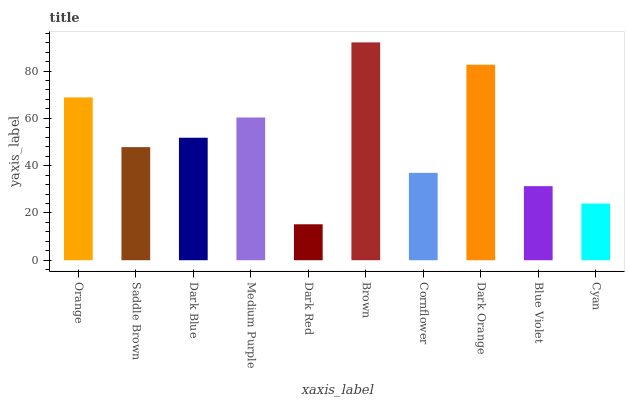Is Saddle Brown the minimum?
Answer yes or no. No. Is Saddle Brown the maximum?
Answer yes or no. No. Is Orange greater than Saddle Brown?
Answer yes or no. Yes. Is Saddle Brown less than Orange?
Answer yes or no. Yes. Is Saddle Brown greater than Orange?
Answer yes or no. No. Is Orange less than Saddle Brown?
Answer yes or no. No. Is Dark Blue the high median?
Answer yes or no. Yes. Is Saddle Brown the low median?
Answer yes or no. Yes. Is Orange the high median?
Answer yes or no. No. Is Blue Violet the low median?
Answer yes or no. No. 